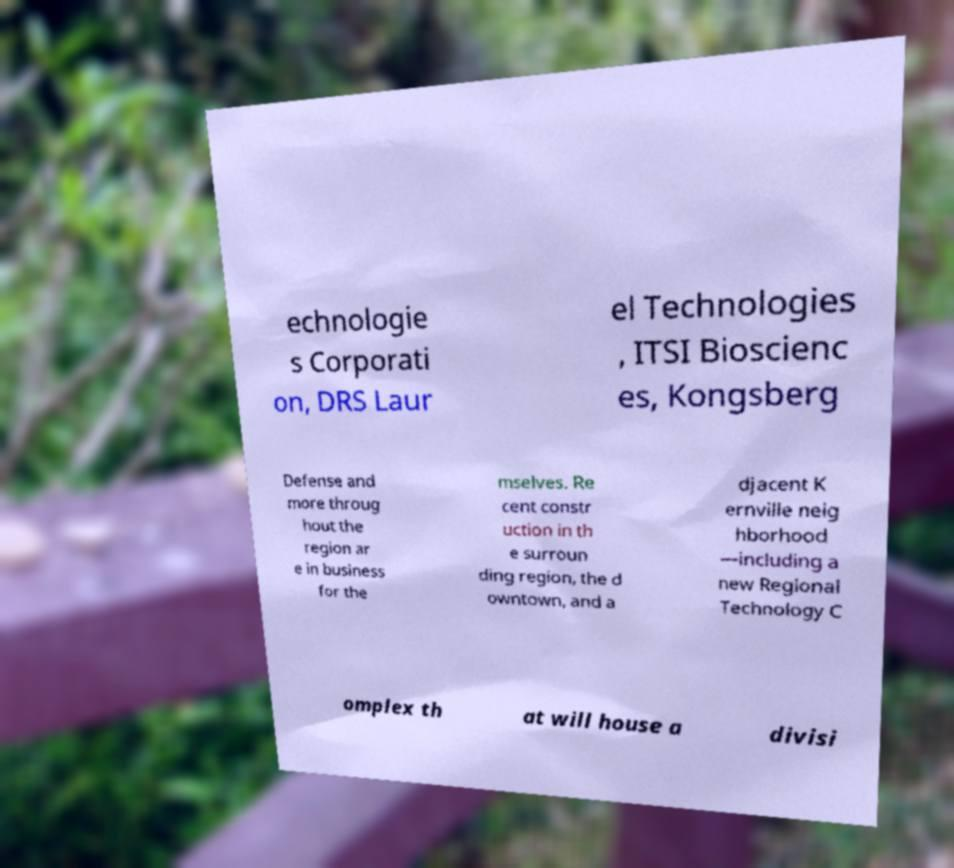Please identify and transcribe the text found in this image. echnologie s Corporati on, DRS Laur el Technologies , ITSI Bioscienc es, Kongsberg Defense and more throug hout the region ar e in business for the mselves. Re cent constr uction in th e surroun ding region, the d owntown, and a djacent K ernville neig hborhood —including a new Regional Technology C omplex th at will house a divisi 